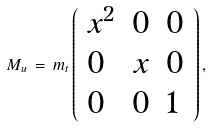Convert formula to latex. <formula><loc_0><loc_0><loc_500><loc_500>M _ { u } \, = \, m _ { t } \left ( \begin{array} { l l l } { { x ^ { 2 } } } & { 0 } & { 0 } \\ { 0 } & { x } & { 0 } \\ { 0 } & { 0 } & { 1 } \end{array} \right ) ,</formula> 